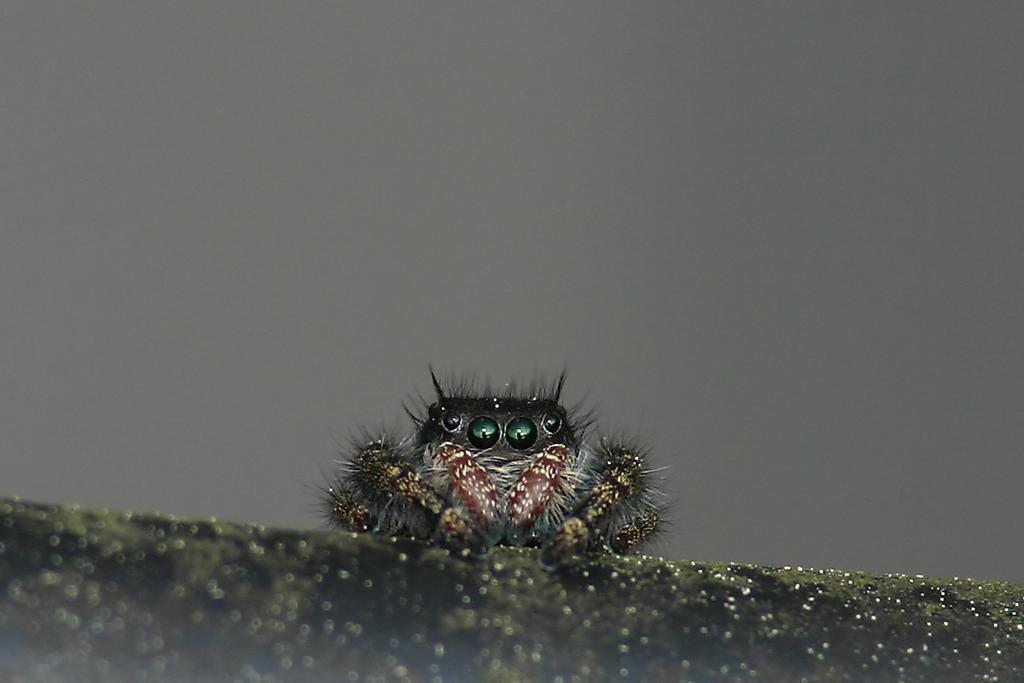What type of creature can be seen in the image? There is an insect in the image. Can you describe the background of the image? The background of the image is blurry. How many women are present in the image? There is no mention of women in the provided facts, so we cannot determine the number of women in the image. What types of pets can be seen in the image? There is no mention of pets in the provided facts, so we cannot determine the types of pets in the image. 